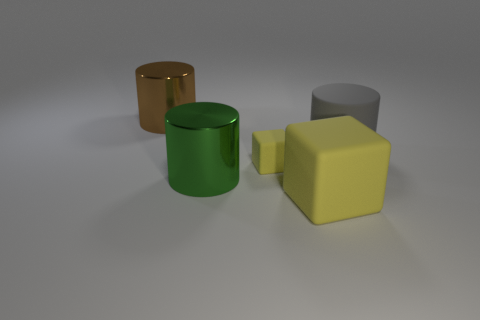Are there any gray things that have the same shape as the tiny yellow object?
Your answer should be very brief. No. What number of things are cylinders that are in front of the small matte cube or large cylinders?
Your response must be concise. 3. What size is the other matte block that is the same color as the big matte block?
Offer a very short reply. Small. There is a big thing that is behind the gray cylinder; is it the same color as the large shiny object in front of the big gray object?
Your answer should be very brief. No. What size is the green cylinder?
Your answer should be compact. Large. How many small things are green metal cylinders or brown objects?
Ensure brevity in your answer.  0. There is a rubber object that is the same size as the rubber cylinder; what color is it?
Your response must be concise. Yellow. How many other objects are there of the same shape as the big gray object?
Make the answer very short. 2. Is there a large green cylinder made of the same material as the small yellow block?
Your response must be concise. No. Is the material of the small yellow object that is in front of the big gray cylinder the same as the large cylinder that is right of the tiny yellow thing?
Your response must be concise. Yes. 